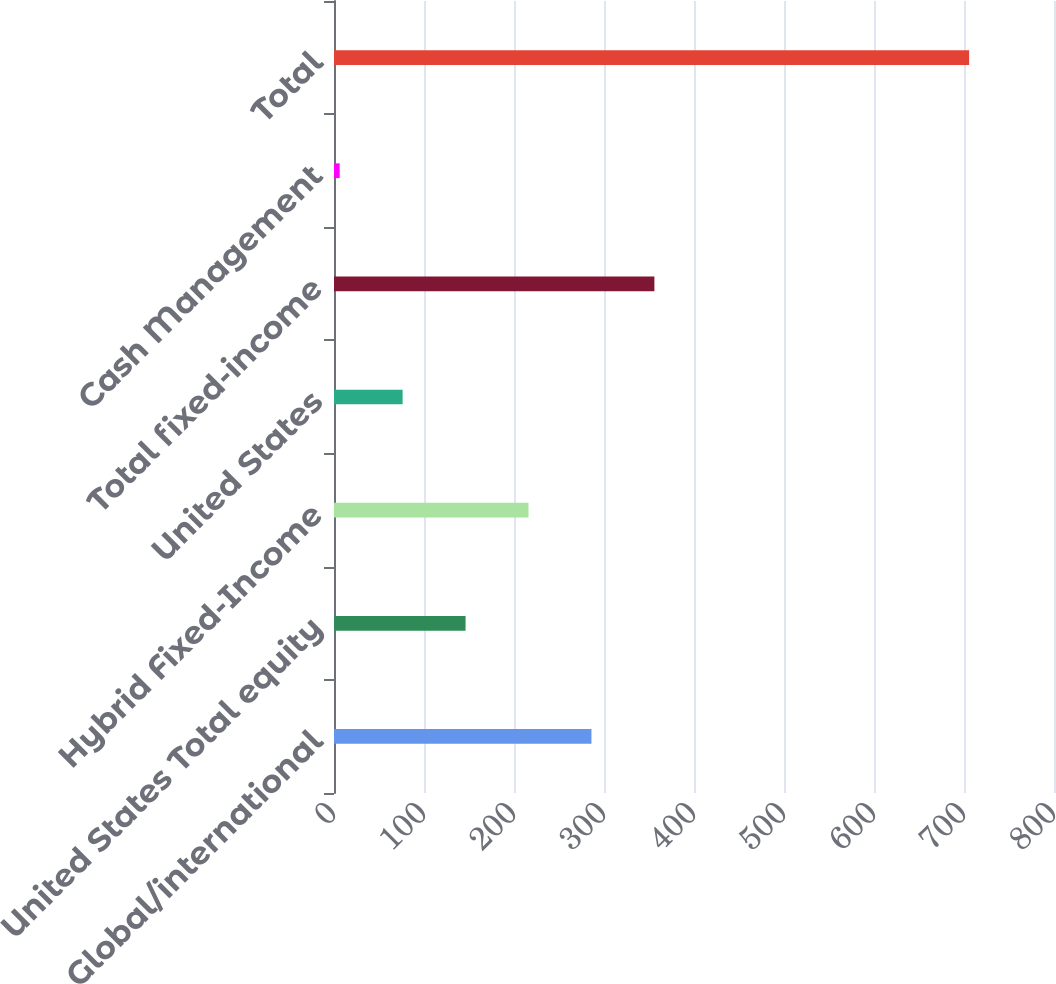<chart> <loc_0><loc_0><loc_500><loc_500><bar_chart><fcel>Global/international<fcel>United States Total equity<fcel>Hybrid Fixed-Income<fcel>United States<fcel>Total fixed-income<fcel>Cash Management<fcel>Total<nl><fcel>286.06<fcel>146.18<fcel>216.12<fcel>76.24<fcel>356<fcel>6.3<fcel>705.7<nl></chart> 